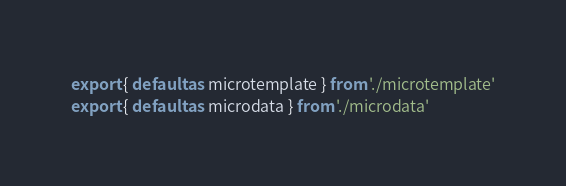Convert code to text. <code><loc_0><loc_0><loc_500><loc_500><_JavaScript_>export { default as microtemplate } from './microtemplate'
export { default as microdata } from './microdata'
</code> 